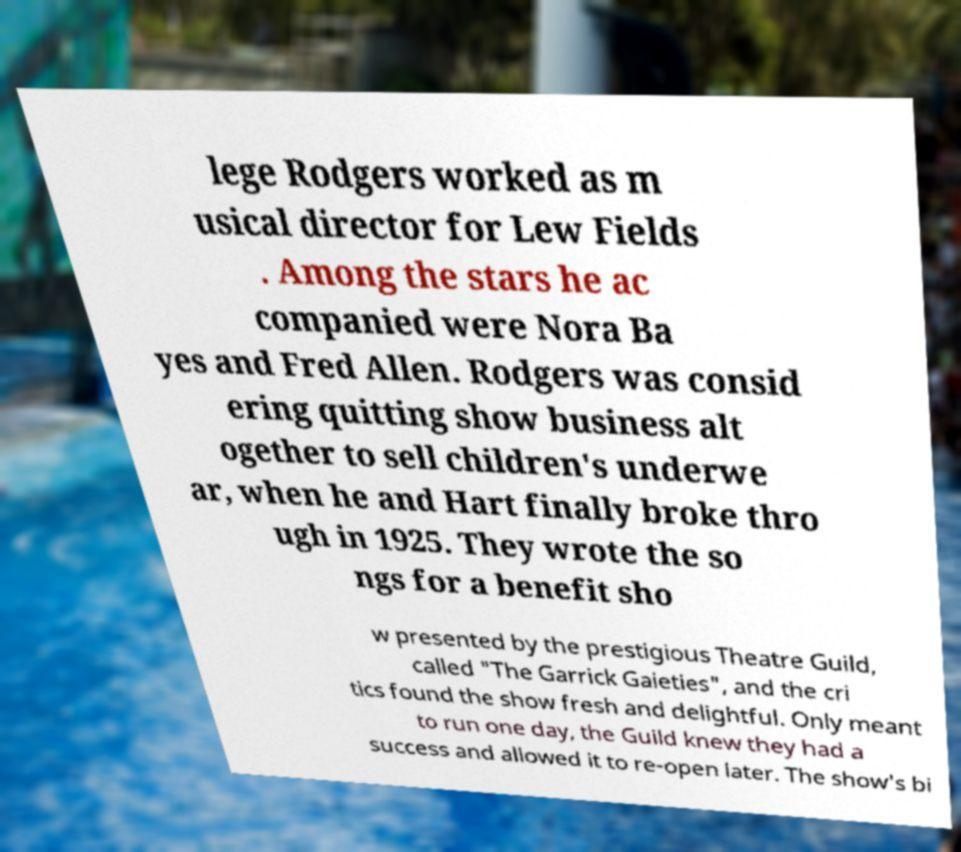Could you assist in decoding the text presented in this image and type it out clearly? lege Rodgers worked as m usical director for Lew Fields . Among the stars he ac companied were Nora Ba yes and Fred Allen. Rodgers was consid ering quitting show business alt ogether to sell children's underwe ar, when he and Hart finally broke thro ugh in 1925. They wrote the so ngs for a benefit sho w presented by the prestigious Theatre Guild, called "The Garrick Gaieties", and the cri tics found the show fresh and delightful. Only meant to run one day, the Guild knew they had a success and allowed it to re-open later. The show's bi 